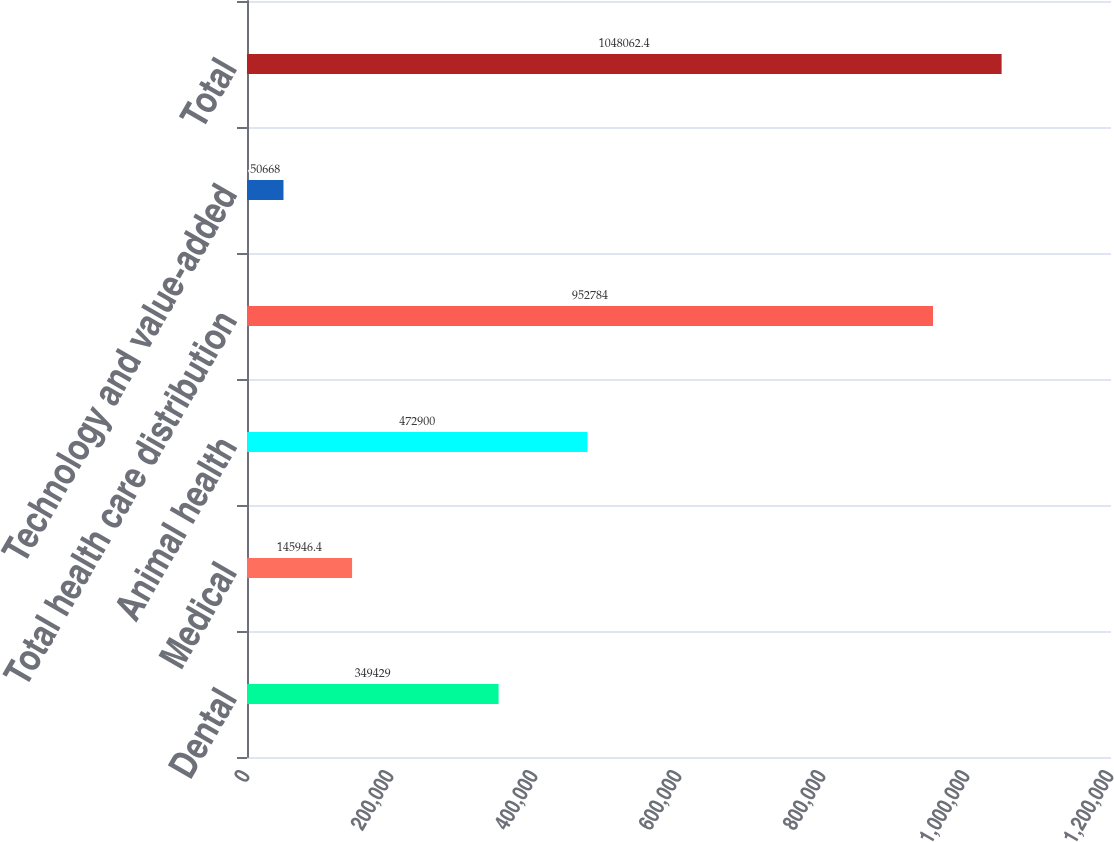Convert chart to OTSL. <chart><loc_0><loc_0><loc_500><loc_500><bar_chart><fcel>Dental<fcel>Medical<fcel>Animal health<fcel>Total health care distribution<fcel>Technology and value-added<fcel>Total<nl><fcel>349429<fcel>145946<fcel>472900<fcel>952784<fcel>50668<fcel>1.04806e+06<nl></chart> 